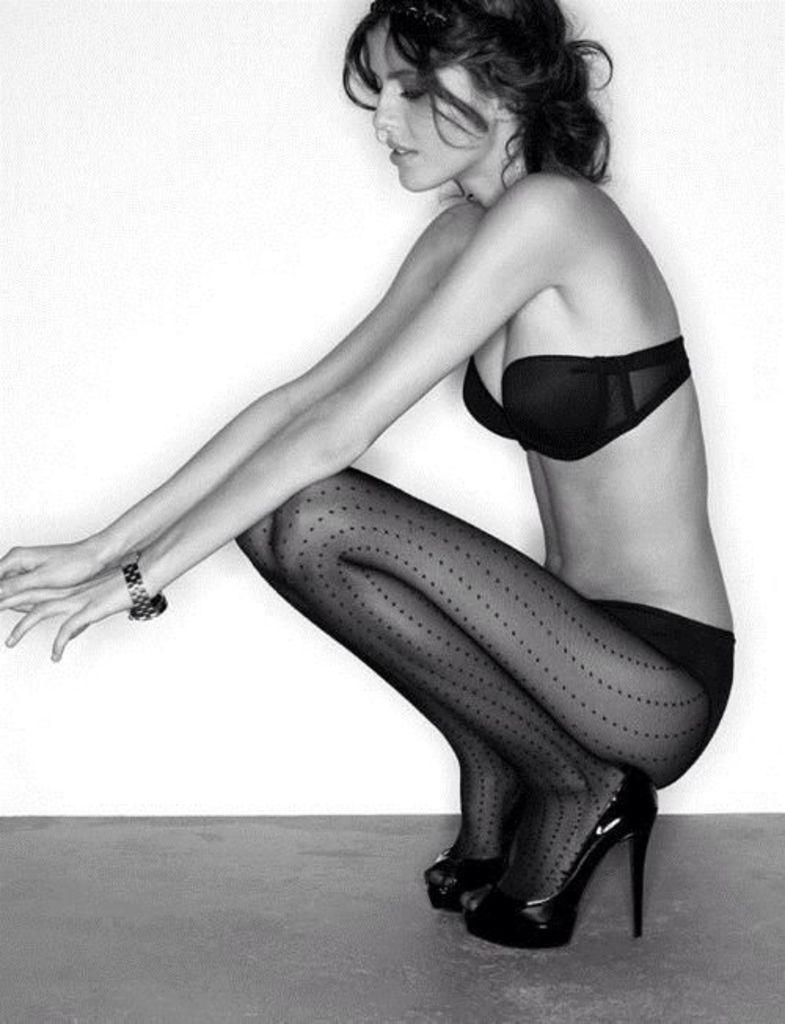Who is the main subject in the image? There is a woman in the image. What type of clothing is the woman wearing? The woman is wearing inner wear. What type of footwear is the woman wearing? The woman is wearing sandals. What accessory is the woman wearing on her wrist? The woman is wearing a wrist watch. How many dogs are playing in the field in the image? There are no dogs or fields present in the image; it features a woman wearing inner wear, sandals, and a wrist watch. 